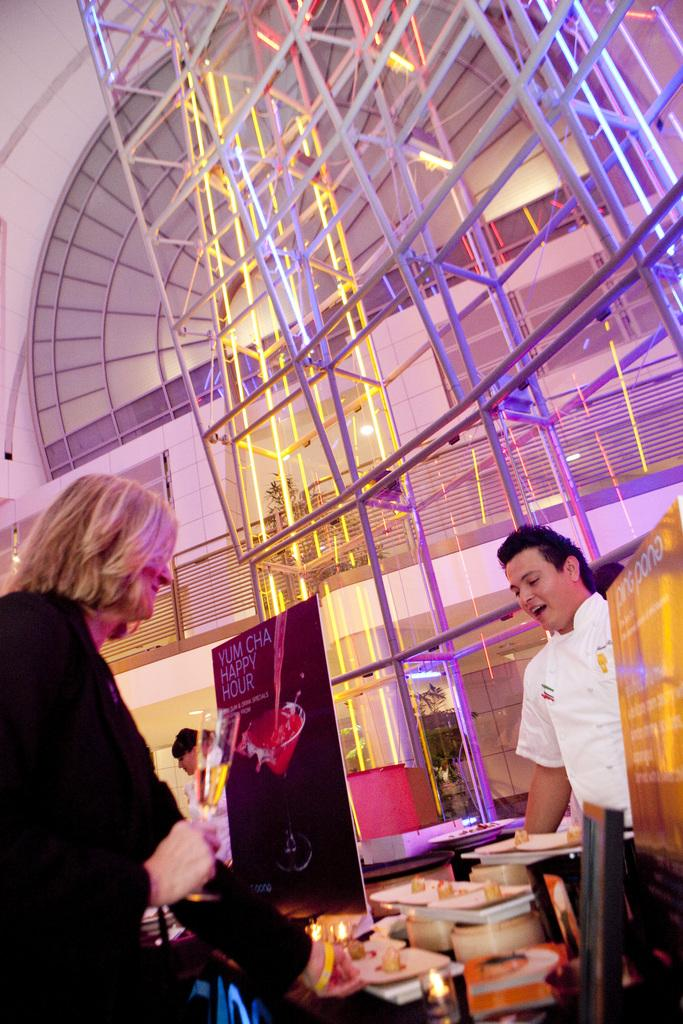What is happening in the image involving the people? There are people standing in the image, and two of them are smiling. What can be seen hanging in the image? There are banners in the image. What material is visible in the image? Glass is visible in the image. What object can be seen in the image that might contain items? There is a box in the image. What objects can be seen in the image that might be used for serving food? There are plates in the image. What long, thin objects can be seen in the image? There are rods in the image. What structures can be seen in the image that might provide boundaries or enclosures? There is a fence and a wall in the image. What other unspecified objects can be seen in the image? There are some unspecified objects in the image. What type of music can be heard playing in the background of the image? There is no indication of music or any sounds in the image, so it's not possible to determine what, if any, music might be heard. 